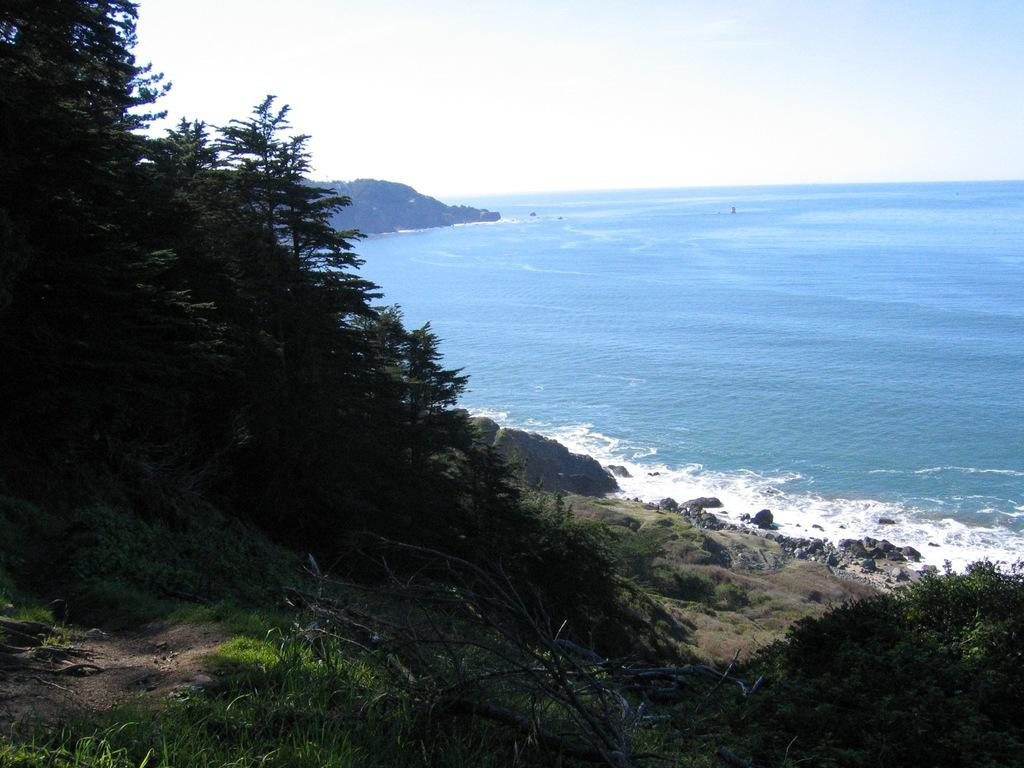What type of vegetation can be seen in the image? There is grass and trees in the image. What other natural elements are present in the image? There are rocks and water visible in the image. What can be seen in the background of the image? The sky is visible in the background of the image. Can you see a crown on top of the trees in the image? There is no crown present in the image; it features grass, trees, rocks, water, and the sky. 